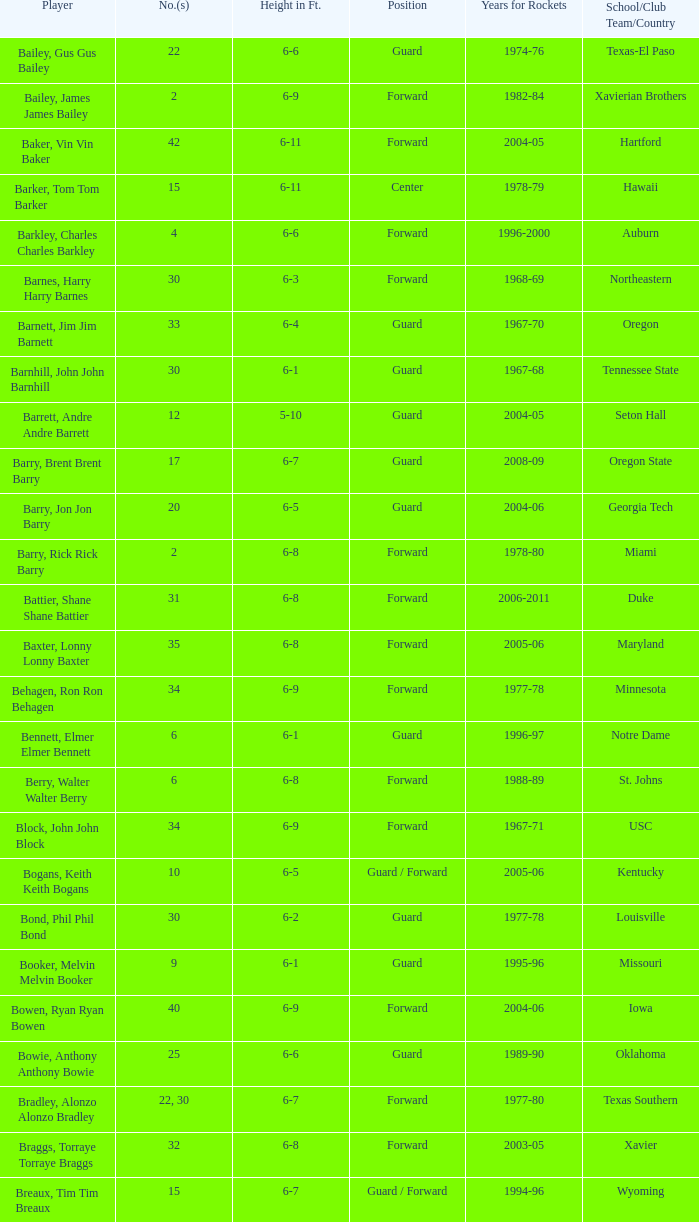What school did the forward whose number is 10 belong to? Arizona. 